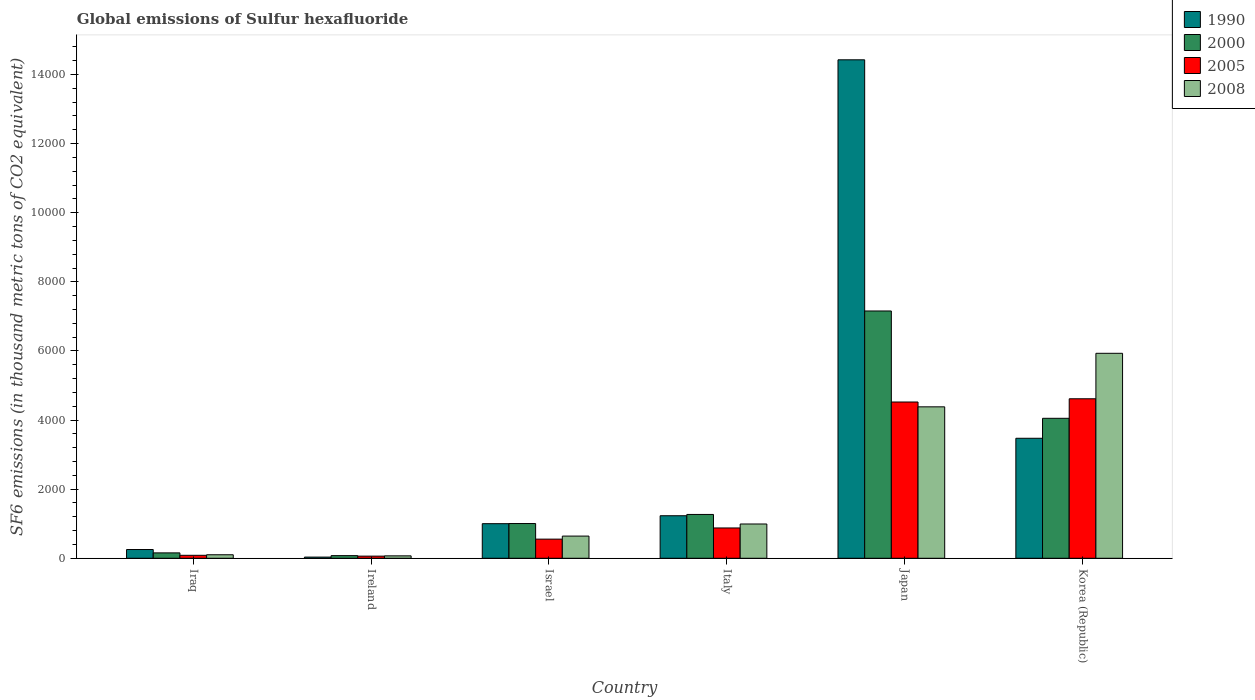Are the number of bars per tick equal to the number of legend labels?
Your answer should be very brief. Yes. How many bars are there on the 3rd tick from the right?
Your response must be concise. 4. What is the label of the 5th group of bars from the left?
Give a very brief answer. Japan. What is the global emissions of Sulfur hexafluoride in 2008 in Japan?
Keep it short and to the point. 4382.7. Across all countries, what is the maximum global emissions of Sulfur hexafluoride in 2005?
Offer a terse response. 4615.7. Across all countries, what is the minimum global emissions of Sulfur hexafluoride in 1990?
Offer a terse response. 33.8. In which country was the global emissions of Sulfur hexafluoride in 2000 minimum?
Keep it short and to the point. Ireland. What is the total global emissions of Sulfur hexafluoride in 1990 in the graph?
Your answer should be compact. 2.04e+04. What is the difference between the global emissions of Sulfur hexafluoride in 2005 in Iraq and that in Korea (Republic)?
Make the answer very short. -4529.7. What is the difference between the global emissions of Sulfur hexafluoride in 2008 in Japan and the global emissions of Sulfur hexafluoride in 2000 in Ireland?
Provide a succinct answer. 4306.2. What is the average global emissions of Sulfur hexafluoride in 2005 per country?
Your response must be concise. 1786.12. What is the difference between the global emissions of Sulfur hexafluoride of/in 2005 and global emissions of Sulfur hexafluoride of/in 1990 in Israel?
Ensure brevity in your answer.  -447.3. What is the ratio of the global emissions of Sulfur hexafluoride in 1990 in Iraq to that in Ireland?
Offer a terse response. 7.48. Is the global emissions of Sulfur hexafluoride in 2005 in Iraq less than that in Korea (Republic)?
Provide a short and direct response. Yes. Is the difference between the global emissions of Sulfur hexafluoride in 2005 in Iraq and Italy greater than the difference between the global emissions of Sulfur hexafluoride in 1990 in Iraq and Italy?
Ensure brevity in your answer.  Yes. What is the difference between the highest and the second highest global emissions of Sulfur hexafluoride in 2005?
Keep it short and to the point. 3645.1. What is the difference between the highest and the lowest global emissions of Sulfur hexafluoride in 1990?
Your response must be concise. 1.44e+04. In how many countries, is the global emissions of Sulfur hexafluoride in 1990 greater than the average global emissions of Sulfur hexafluoride in 1990 taken over all countries?
Your answer should be compact. 2. Is it the case that in every country, the sum of the global emissions of Sulfur hexafluoride in 2000 and global emissions of Sulfur hexafluoride in 1990 is greater than the sum of global emissions of Sulfur hexafluoride in 2008 and global emissions of Sulfur hexafluoride in 2005?
Ensure brevity in your answer.  No. What does the 3rd bar from the right in Japan represents?
Your answer should be compact. 2000. Is it the case that in every country, the sum of the global emissions of Sulfur hexafluoride in 2000 and global emissions of Sulfur hexafluoride in 2008 is greater than the global emissions of Sulfur hexafluoride in 1990?
Provide a short and direct response. No. How many bars are there?
Offer a very short reply. 24. How many countries are there in the graph?
Give a very brief answer. 6. Are the values on the major ticks of Y-axis written in scientific E-notation?
Make the answer very short. No. Does the graph contain any zero values?
Provide a succinct answer. No. Does the graph contain grids?
Your answer should be compact. No. How many legend labels are there?
Your answer should be compact. 4. What is the title of the graph?
Your answer should be very brief. Global emissions of Sulfur hexafluoride. What is the label or title of the X-axis?
Offer a very short reply. Country. What is the label or title of the Y-axis?
Offer a very short reply. SF6 emissions (in thousand metric tons of CO2 equivalent). What is the SF6 emissions (in thousand metric tons of CO2 equivalent) of 1990 in Iraq?
Give a very brief answer. 252.9. What is the SF6 emissions (in thousand metric tons of CO2 equivalent) of 2000 in Iraq?
Give a very brief answer. 156.1. What is the SF6 emissions (in thousand metric tons of CO2 equivalent) in 2005 in Iraq?
Ensure brevity in your answer.  86. What is the SF6 emissions (in thousand metric tons of CO2 equivalent) of 2008 in Iraq?
Offer a very short reply. 101.7. What is the SF6 emissions (in thousand metric tons of CO2 equivalent) in 1990 in Ireland?
Your answer should be compact. 33.8. What is the SF6 emissions (in thousand metric tons of CO2 equivalent) in 2000 in Ireland?
Provide a short and direct response. 76.5. What is the SF6 emissions (in thousand metric tons of CO2 equivalent) of 2005 in Ireland?
Make the answer very short. 61.8. What is the SF6 emissions (in thousand metric tons of CO2 equivalent) in 2008 in Ireland?
Keep it short and to the point. 69.9. What is the SF6 emissions (in thousand metric tons of CO2 equivalent) of 1990 in Israel?
Provide a succinct answer. 1001. What is the SF6 emissions (in thousand metric tons of CO2 equivalent) of 2000 in Israel?
Ensure brevity in your answer.  1005.2. What is the SF6 emissions (in thousand metric tons of CO2 equivalent) in 2005 in Israel?
Your answer should be compact. 553.7. What is the SF6 emissions (in thousand metric tons of CO2 equivalent) in 2008 in Israel?
Your answer should be very brief. 642. What is the SF6 emissions (in thousand metric tons of CO2 equivalent) of 1990 in Italy?
Provide a short and direct response. 1230.8. What is the SF6 emissions (in thousand metric tons of CO2 equivalent) in 2000 in Italy?
Provide a succinct answer. 1268.5. What is the SF6 emissions (in thousand metric tons of CO2 equivalent) in 2005 in Italy?
Ensure brevity in your answer.  877.2. What is the SF6 emissions (in thousand metric tons of CO2 equivalent) in 2008 in Italy?
Provide a short and direct response. 992.1. What is the SF6 emissions (in thousand metric tons of CO2 equivalent) of 1990 in Japan?
Make the answer very short. 1.44e+04. What is the SF6 emissions (in thousand metric tons of CO2 equivalent) of 2000 in Japan?
Offer a very short reply. 7156.6. What is the SF6 emissions (in thousand metric tons of CO2 equivalent) of 2005 in Japan?
Ensure brevity in your answer.  4522.3. What is the SF6 emissions (in thousand metric tons of CO2 equivalent) in 2008 in Japan?
Your response must be concise. 4382.7. What is the SF6 emissions (in thousand metric tons of CO2 equivalent) of 1990 in Korea (Republic)?
Keep it short and to the point. 3472.9. What is the SF6 emissions (in thousand metric tons of CO2 equivalent) of 2000 in Korea (Republic)?
Make the answer very short. 4050.5. What is the SF6 emissions (in thousand metric tons of CO2 equivalent) in 2005 in Korea (Republic)?
Make the answer very short. 4615.7. What is the SF6 emissions (in thousand metric tons of CO2 equivalent) in 2008 in Korea (Republic)?
Ensure brevity in your answer.  5931.6. Across all countries, what is the maximum SF6 emissions (in thousand metric tons of CO2 equivalent) in 1990?
Give a very brief answer. 1.44e+04. Across all countries, what is the maximum SF6 emissions (in thousand metric tons of CO2 equivalent) in 2000?
Make the answer very short. 7156.6. Across all countries, what is the maximum SF6 emissions (in thousand metric tons of CO2 equivalent) in 2005?
Ensure brevity in your answer.  4615.7. Across all countries, what is the maximum SF6 emissions (in thousand metric tons of CO2 equivalent) in 2008?
Ensure brevity in your answer.  5931.6. Across all countries, what is the minimum SF6 emissions (in thousand metric tons of CO2 equivalent) of 1990?
Your answer should be very brief. 33.8. Across all countries, what is the minimum SF6 emissions (in thousand metric tons of CO2 equivalent) in 2000?
Your response must be concise. 76.5. Across all countries, what is the minimum SF6 emissions (in thousand metric tons of CO2 equivalent) in 2005?
Your response must be concise. 61.8. Across all countries, what is the minimum SF6 emissions (in thousand metric tons of CO2 equivalent) in 2008?
Make the answer very short. 69.9. What is the total SF6 emissions (in thousand metric tons of CO2 equivalent) of 1990 in the graph?
Your answer should be very brief. 2.04e+04. What is the total SF6 emissions (in thousand metric tons of CO2 equivalent) in 2000 in the graph?
Give a very brief answer. 1.37e+04. What is the total SF6 emissions (in thousand metric tons of CO2 equivalent) of 2005 in the graph?
Make the answer very short. 1.07e+04. What is the total SF6 emissions (in thousand metric tons of CO2 equivalent) of 2008 in the graph?
Your answer should be very brief. 1.21e+04. What is the difference between the SF6 emissions (in thousand metric tons of CO2 equivalent) in 1990 in Iraq and that in Ireland?
Make the answer very short. 219.1. What is the difference between the SF6 emissions (in thousand metric tons of CO2 equivalent) in 2000 in Iraq and that in Ireland?
Your answer should be compact. 79.6. What is the difference between the SF6 emissions (in thousand metric tons of CO2 equivalent) in 2005 in Iraq and that in Ireland?
Ensure brevity in your answer.  24.2. What is the difference between the SF6 emissions (in thousand metric tons of CO2 equivalent) in 2008 in Iraq and that in Ireland?
Keep it short and to the point. 31.8. What is the difference between the SF6 emissions (in thousand metric tons of CO2 equivalent) in 1990 in Iraq and that in Israel?
Your response must be concise. -748.1. What is the difference between the SF6 emissions (in thousand metric tons of CO2 equivalent) in 2000 in Iraq and that in Israel?
Your answer should be compact. -849.1. What is the difference between the SF6 emissions (in thousand metric tons of CO2 equivalent) of 2005 in Iraq and that in Israel?
Provide a succinct answer. -467.7. What is the difference between the SF6 emissions (in thousand metric tons of CO2 equivalent) in 2008 in Iraq and that in Israel?
Offer a terse response. -540.3. What is the difference between the SF6 emissions (in thousand metric tons of CO2 equivalent) of 1990 in Iraq and that in Italy?
Ensure brevity in your answer.  -977.9. What is the difference between the SF6 emissions (in thousand metric tons of CO2 equivalent) of 2000 in Iraq and that in Italy?
Ensure brevity in your answer.  -1112.4. What is the difference between the SF6 emissions (in thousand metric tons of CO2 equivalent) in 2005 in Iraq and that in Italy?
Provide a short and direct response. -791.2. What is the difference between the SF6 emissions (in thousand metric tons of CO2 equivalent) of 2008 in Iraq and that in Italy?
Make the answer very short. -890.4. What is the difference between the SF6 emissions (in thousand metric tons of CO2 equivalent) of 1990 in Iraq and that in Japan?
Offer a terse response. -1.42e+04. What is the difference between the SF6 emissions (in thousand metric tons of CO2 equivalent) of 2000 in Iraq and that in Japan?
Your answer should be compact. -7000.5. What is the difference between the SF6 emissions (in thousand metric tons of CO2 equivalent) in 2005 in Iraq and that in Japan?
Keep it short and to the point. -4436.3. What is the difference between the SF6 emissions (in thousand metric tons of CO2 equivalent) in 2008 in Iraq and that in Japan?
Offer a very short reply. -4281. What is the difference between the SF6 emissions (in thousand metric tons of CO2 equivalent) of 1990 in Iraq and that in Korea (Republic)?
Your answer should be very brief. -3220. What is the difference between the SF6 emissions (in thousand metric tons of CO2 equivalent) of 2000 in Iraq and that in Korea (Republic)?
Your answer should be very brief. -3894.4. What is the difference between the SF6 emissions (in thousand metric tons of CO2 equivalent) in 2005 in Iraq and that in Korea (Republic)?
Your answer should be very brief. -4529.7. What is the difference between the SF6 emissions (in thousand metric tons of CO2 equivalent) of 2008 in Iraq and that in Korea (Republic)?
Offer a terse response. -5829.9. What is the difference between the SF6 emissions (in thousand metric tons of CO2 equivalent) in 1990 in Ireland and that in Israel?
Your answer should be compact. -967.2. What is the difference between the SF6 emissions (in thousand metric tons of CO2 equivalent) of 2000 in Ireland and that in Israel?
Give a very brief answer. -928.7. What is the difference between the SF6 emissions (in thousand metric tons of CO2 equivalent) in 2005 in Ireland and that in Israel?
Your answer should be very brief. -491.9. What is the difference between the SF6 emissions (in thousand metric tons of CO2 equivalent) of 2008 in Ireland and that in Israel?
Provide a short and direct response. -572.1. What is the difference between the SF6 emissions (in thousand metric tons of CO2 equivalent) in 1990 in Ireland and that in Italy?
Offer a terse response. -1197. What is the difference between the SF6 emissions (in thousand metric tons of CO2 equivalent) in 2000 in Ireland and that in Italy?
Your answer should be compact. -1192. What is the difference between the SF6 emissions (in thousand metric tons of CO2 equivalent) in 2005 in Ireland and that in Italy?
Provide a short and direct response. -815.4. What is the difference between the SF6 emissions (in thousand metric tons of CO2 equivalent) of 2008 in Ireland and that in Italy?
Your answer should be very brief. -922.2. What is the difference between the SF6 emissions (in thousand metric tons of CO2 equivalent) in 1990 in Ireland and that in Japan?
Keep it short and to the point. -1.44e+04. What is the difference between the SF6 emissions (in thousand metric tons of CO2 equivalent) in 2000 in Ireland and that in Japan?
Your answer should be very brief. -7080.1. What is the difference between the SF6 emissions (in thousand metric tons of CO2 equivalent) of 2005 in Ireland and that in Japan?
Provide a succinct answer. -4460.5. What is the difference between the SF6 emissions (in thousand metric tons of CO2 equivalent) in 2008 in Ireland and that in Japan?
Keep it short and to the point. -4312.8. What is the difference between the SF6 emissions (in thousand metric tons of CO2 equivalent) of 1990 in Ireland and that in Korea (Republic)?
Your answer should be compact. -3439.1. What is the difference between the SF6 emissions (in thousand metric tons of CO2 equivalent) in 2000 in Ireland and that in Korea (Republic)?
Keep it short and to the point. -3974. What is the difference between the SF6 emissions (in thousand metric tons of CO2 equivalent) of 2005 in Ireland and that in Korea (Republic)?
Provide a short and direct response. -4553.9. What is the difference between the SF6 emissions (in thousand metric tons of CO2 equivalent) in 2008 in Ireland and that in Korea (Republic)?
Provide a succinct answer. -5861.7. What is the difference between the SF6 emissions (in thousand metric tons of CO2 equivalent) of 1990 in Israel and that in Italy?
Keep it short and to the point. -229.8. What is the difference between the SF6 emissions (in thousand metric tons of CO2 equivalent) in 2000 in Israel and that in Italy?
Make the answer very short. -263.3. What is the difference between the SF6 emissions (in thousand metric tons of CO2 equivalent) of 2005 in Israel and that in Italy?
Your answer should be compact. -323.5. What is the difference between the SF6 emissions (in thousand metric tons of CO2 equivalent) of 2008 in Israel and that in Italy?
Provide a succinct answer. -350.1. What is the difference between the SF6 emissions (in thousand metric tons of CO2 equivalent) in 1990 in Israel and that in Japan?
Ensure brevity in your answer.  -1.34e+04. What is the difference between the SF6 emissions (in thousand metric tons of CO2 equivalent) of 2000 in Israel and that in Japan?
Your answer should be compact. -6151.4. What is the difference between the SF6 emissions (in thousand metric tons of CO2 equivalent) in 2005 in Israel and that in Japan?
Your answer should be very brief. -3968.6. What is the difference between the SF6 emissions (in thousand metric tons of CO2 equivalent) of 2008 in Israel and that in Japan?
Offer a terse response. -3740.7. What is the difference between the SF6 emissions (in thousand metric tons of CO2 equivalent) in 1990 in Israel and that in Korea (Republic)?
Your answer should be compact. -2471.9. What is the difference between the SF6 emissions (in thousand metric tons of CO2 equivalent) of 2000 in Israel and that in Korea (Republic)?
Offer a very short reply. -3045.3. What is the difference between the SF6 emissions (in thousand metric tons of CO2 equivalent) in 2005 in Israel and that in Korea (Republic)?
Your response must be concise. -4062. What is the difference between the SF6 emissions (in thousand metric tons of CO2 equivalent) in 2008 in Israel and that in Korea (Republic)?
Provide a succinct answer. -5289.6. What is the difference between the SF6 emissions (in thousand metric tons of CO2 equivalent) in 1990 in Italy and that in Japan?
Ensure brevity in your answer.  -1.32e+04. What is the difference between the SF6 emissions (in thousand metric tons of CO2 equivalent) of 2000 in Italy and that in Japan?
Ensure brevity in your answer.  -5888.1. What is the difference between the SF6 emissions (in thousand metric tons of CO2 equivalent) of 2005 in Italy and that in Japan?
Provide a short and direct response. -3645.1. What is the difference between the SF6 emissions (in thousand metric tons of CO2 equivalent) of 2008 in Italy and that in Japan?
Keep it short and to the point. -3390.6. What is the difference between the SF6 emissions (in thousand metric tons of CO2 equivalent) of 1990 in Italy and that in Korea (Republic)?
Give a very brief answer. -2242.1. What is the difference between the SF6 emissions (in thousand metric tons of CO2 equivalent) of 2000 in Italy and that in Korea (Republic)?
Make the answer very short. -2782. What is the difference between the SF6 emissions (in thousand metric tons of CO2 equivalent) of 2005 in Italy and that in Korea (Republic)?
Your answer should be very brief. -3738.5. What is the difference between the SF6 emissions (in thousand metric tons of CO2 equivalent) of 2008 in Italy and that in Korea (Republic)?
Offer a terse response. -4939.5. What is the difference between the SF6 emissions (in thousand metric tons of CO2 equivalent) of 1990 in Japan and that in Korea (Republic)?
Your response must be concise. 1.10e+04. What is the difference between the SF6 emissions (in thousand metric tons of CO2 equivalent) of 2000 in Japan and that in Korea (Republic)?
Keep it short and to the point. 3106.1. What is the difference between the SF6 emissions (in thousand metric tons of CO2 equivalent) of 2005 in Japan and that in Korea (Republic)?
Offer a terse response. -93.4. What is the difference between the SF6 emissions (in thousand metric tons of CO2 equivalent) of 2008 in Japan and that in Korea (Republic)?
Make the answer very short. -1548.9. What is the difference between the SF6 emissions (in thousand metric tons of CO2 equivalent) of 1990 in Iraq and the SF6 emissions (in thousand metric tons of CO2 equivalent) of 2000 in Ireland?
Your answer should be compact. 176.4. What is the difference between the SF6 emissions (in thousand metric tons of CO2 equivalent) of 1990 in Iraq and the SF6 emissions (in thousand metric tons of CO2 equivalent) of 2005 in Ireland?
Provide a short and direct response. 191.1. What is the difference between the SF6 emissions (in thousand metric tons of CO2 equivalent) of 1990 in Iraq and the SF6 emissions (in thousand metric tons of CO2 equivalent) of 2008 in Ireland?
Your answer should be very brief. 183. What is the difference between the SF6 emissions (in thousand metric tons of CO2 equivalent) of 2000 in Iraq and the SF6 emissions (in thousand metric tons of CO2 equivalent) of 2005 in Ireland?
Give a very brief answer. 94.3. What is the difference between the SF6 emissions (in thousand metric tons of CO2 equivalent) of 2000 in Iraq and the SF6 emissions (in thousand metric tons of CO2 equivalent) of 2008 in Ireland?
Your answer should be compact. 86.2. What is the difference between the SF6 emissions (in thousand metric tons of CO2 equivalent) of 1990 in Iraq and the SF6 emissions (in thousand metric tons of CO2 equivalent) of 2000 in Israel?
Provide a succinct answer. -752.3. What is the difference between the SF6 emissions (in thousand metric tons of CO2 equivalent) in 1990 in Iraq and the SF6 emissions (in thousand metric tons of CO2 equivalent) in 2005 in Israel?
Keep it short and to the point. -300.8. What is the difference between the SF6 emissions (in thousand metric tons of CO2 equivalent) of 1990 in Iraq and the SF6 emissions (in thousand metric tons of CO2 equivalent) of 2008 in Israel?
Give a very brief answer. -389.1. What is the difference between the SF6 emissions (in thousand metric tons of CO2 equivalent) in 2000 in Iraq and the SF6 emissions (in thousand metric tons of CO2 equivalent) in 2005 in Israel?
Give a very brief answer. -397.6. What is the difference between the SF6 emissions (in thousand metric tons of CO2 equivalent) in 2000 in Iraq and the SF6 emissions (in thousand metric tons of CO2 equivalent) in 2008 in Israel?
Keep it short and to the point. -485.9. What is the difference between the SF6 emissions (in thousand metric tons of CO2 equivalent) in 2005 in Iraq and the SF6 emissions (in thousand metric tons of CO2 equivalent) in 2008 in Israel?
Offer a very short reply. -556. What is the difference between the SF6 emissions (in thousand metric tons of CO2 equivalent) in 1990 in Iraq and the SF6 emissions (in thousand metric tons of CO2 equivalent) in 2000 in Italy?
Your answer should be compact. -1015.6. What is the difference between the SF6 emissions (in thousand metric tons of CO2 equivalent) in 1990 in Iraq and the SF6 emissions (in thousand metric tons of CO2 equivalent) in 2005 in Italy?
Ensure brevity in your answer.  -624.3. What is the difference between the SF6 emissions (in thousand metric tons of CO2 equivalent) in 1990 in Iraq and the SF6 emissions (in thousand metric tons of CO2 equivalent) in 2008 in Italy?
Your answer should be compact. -739.2. What is the difference between the SF6 emissions (in thousand metric tons of CO2 equivalent) in 2000 in Iraq and the SF6 emissions (in thousand metric tons of CO2 equivalent) in 2005 in Italy?
Offer a terse response. -721.1. What is the difference between the SF6 emissions (in thousand metric tons of CO2 equivalent) of 2000 in Iraq and the SF6 emissions (in thousand metric tons of CO2 equivalent) of 2008 in Italy?
Make the answer very short. -836. What is the difference between the SF6 emissions (in thousand metric tons of CO2 equivalent) in 2005 in Iraq and the SF6 emissions (in thousand metric tons of CO2 equivalent) in 2008 in Italy?
Offer a terse response. -906.1. What is the difference between the SF6 emissions (in thousand metric tons of CO2 equivalent) in 1990 in Iraq and the SF6 emissions (in thousand metric tons of CO2 equivalent) in 2000 in Japan?
Your response must be concise. -6903.7. What is the difference between the SF6 emissions (in thousand metric tons of CO2 equivalent) of 1990 in Iraq and the SF6 emissions (in thousand metric tons of CO2 equivalent) of 2005 in Japan?
Make the answer very short. -4269.4. What is the difference between the SF6 emissions (in thousand metric tons of CO2 equivalent) in 1990 in Iraq and the SF6 emissions (in thousand metric tons of CO2 equivalent) in 2008 in Japan?
Provide a short and direct response. -4129.8. What is the difference between the SF6 emissions (in thousand metric tons of CO2 equivalent) in 2000 in Iraq and the SF6 emissions (in thousand metric tons of CO2 equivalent) in 2005 in Japan?
Offer a very short reply. -4366.2. What is the difference between the SF6 emissions (in thousand metric tons of CO2 equivalent) in 2000 in Iraq and the SF6 emissions (in thousand metric tons of CO2 equivalent) in 2008 in Japan?
Your response must be concise. -4226.6. What is the difference between the SF6 emissions (in thousand metric tons of CO2 equivalent) in 2005 in Iraq and the SF6 emissions (in thousand metric tons of CO2 equivalent) in 2008 in Japan?
Keep it short and to the point. -4296.7. What is the difference between the SF6 emissions (in thousand metric tons of CO2 equivalent) in 1990 in Iraq and the SF6 emissions (in thousand metric tons of CO2 equivalent) in 2000 in Korea (Republic)?
Your answer should be compact. -3797.6. What is the difference between the SF6 emissions (in thousand metric tons of CO2 equivalent) of 1990 in Iraq and the SF6 emissions (in thousand metric tons of CO2 equivalent) of 2005 in Korea (Republic)?
Offer a terse response. -4362.8. What is the difference between the SF6 emissions (in thousand metric tons of CO2 equivalent) in 1990 in Iraq and the SF6 emissions (in thousand metric tons of CO2 equivalent) in 2008 in Korea (Republic)?
Offer a terse response. -5678.7. What is the difference between the SF6 emissions (in thousand metric tons of CO2 equivalent) in 2000 in Iraq and the SF6 emissions (in thousand metric tons of CO2 equivalent) in 2005 in Korea (Republic)?
Give a very brief answer. -4459.6. What is the difference between the SF6 emissions (in thousand metric tons of CO2 equivalent) of 2000 in Iraq and the SF6 emissions (in thousand metric tons of CO2 equivalent) of 2008 in Korea (Republic)?
Keep it short and to the point. -5775.5. What is the difference between the SF6 emissions (in thousand metric tons of CO2 equivalent) of 2005 in Iraq and the SF6 emissions (in thousand metric tons of CO2 equivalent) of 2008 in Korea (Republic)?
Ensure brevity in your answer.  -5845.6. What is the difference between the SF6 emissions (in thousand metric tons of CO2 equivalent) in 1990 in Ireland and the SF6 emissions (in thousand metric tons of CO2 equivalent) in 2000 in Israel?
Ensure brevity in your answer.  -971.4. What is the difference between the SF6 emissions (in thousand metric tons of CO2 equivalent) in 1990 in Ireland and the SF6 emissions (in thousand metric tons of CO2 equivalent) in 2005 in Israel?
Your response must be concise. -519.9. What is the difference between the SF6 emissions (in thousand metric tons of CO2 equivalent) of 1990 in Ireland and the SF6 emissions (in thousand metric tons of CO2 equivalent) of 2008 in Israel?
Provide a short and direct response. -608.2. What is the difference between the SF6 emissions (in thousand metric tons of CO2 equivalent) in 2000 in Ireland and the SF6 emissions (in thousand metric tons of CO2 equivalent) in 2005 in Israel?
Keep it short and to the point. -477.2. What is the difference between the SF6 emissions (in thousand metric tons of CO2 equivalent) in 2000 in Ireland and the SF6 emissions (in thousand metric tons of CO2 equivalent) in 2008 in Israel?
Your answer should be very brief. -565.5. What is the difference between the SF6 emissions (in thousand metric tons of CO2 equivalent) in 2005 in Ireland and the SF6 emissions (in thousand metric tons of CO2 equivalent) in 2008 in Israel?
Offer a very short reply. -580.2. What is the difference between the SF6 emissions (in thousand metric tons of CO2 equivalent) of 1990 in Ireland and the SF6 emissions (in thousand metric tons of CO2 equivalent) of 2000 in Italy?
Your response must be concise. -1234.7. What is the difference between the SF6 emissions (in thousand metric tons of CO2 equivalent) of 1990 in Ireland and the SF6 emissions (in thousand metric tons of CO2 equivalent) of 2005 in Italy?
Provide a succinct answer. -843.4. What is the difference between the SF6 emissions (in thousand metric tons of CO2 equivalent) of 1990 in Ireland and the SF6 emissions (in thousand metric tons of CO2 equivalent) of 2008 in Italy?
Your response must be concise. -958.3. What is the difference between the SF6 emissions (in thousand metric tons of CO2 equivalent) of 2000 in Ireland and the SF6 emissions (in thousand metric tons of CO2 equivalent) of 2005 in Italy?
Give a very brief answer. -800.7. What is the difference between the SF6 emissions (in thousand metric tons of CO2 equivalent) in 2000 in Ireland and the SF6 emissions (in thousand metric tons of CO2 equivalent) in 2008 in Italy?
Make the answer very short. -915.6. What is the difference between the SF6 emissions (in thousand metric tons of CO2 equivalent) of 2005 in Ireland and the SF6 emissions (in thousand metric tons of CO2 equivalent) of 2008 in Italy?
Your answer should be compact. -930.3. What is the difference between the SF6 emissions (in thousand metric tons of CO2 equivalent) of 1990 in Ireland and the SF6 emissions (in thousand metric tons of CO2 equivalent) of 2000 in Japan?
Give a very brief answer. -7122.8. What is the difference between the SF6 emissions (in thousand metric tons of CO2 equivalent) of 1990 in Ireland and the SF6 emissions (in thousand metric tons of CO2 equivalent) of 2005 in Japan?
Your answer should be compact. -4488.5. What is the difference between the SF6 emissions (in thousand metric tons of CO2 equivalent) in 1990 in Ireland and the SF6 emissions (in thousand metric tons of CO2 equivalent) in 2008 in Japan?
Keep it short and to the point. -4348.9. What is the difference between the SF6 emissions (in thousand metric tons of CO2 equivalent) in 2000 in Ireland and the SF6 emissions (in thousand metric tons of CO2 equivalent) in 2005 in Japan?
Give a very brief answer. -4445.8. What is the difference between the SF6 emissions (in thousand metric tons of CO2 equivalent) of 2000 in Ireland and the SF6 emissions (in thousand metric tons of CO2 equivalent) of 2008 in Japan?
Offer a terse response. -4306.2. What is the difference between the SF6 emissions (in thousand metric tons of CO2 equivalent) of 2005 in Ireland and the SF6 emissions (in thousand metric tons of CO2 equivalent) of 2008 in Japan?
Provide a short and direct response. -4320.9. What is the difference between the SF6 emissions (in thousand metric tons of CO2 equivalent) in 1990 in Ireland and the SF6 emissions (in thousand metric tons of CO2 equivalent) in 2000 in Korea (Republic)?
Make the answer very short. -4016.7. What is the difference between the SF6 emissions (in thousand metric tons of CO2 equivalent) of 1990 in Ireland and the SF6 emissions (in thousand metric tons of CO2 equivalent) of 2005 in Korea (Republic)?
Provide a succinct answer. -4581.9. What is the difference between the SF6 emissions (in thousand metric tons of CO2 equivalent) of 1990 in Ireland and the SF6 emissions (in thousand metric tons of CO2 equivalent) of 2008 in Korea (Republic)?
Provide a short and direct response. -5897.8. What is the difference between the SF6 emissions (in thousand metric tons of CO2 equivalent) of 2000 in Ireland and the SF6 emissions (in thousand metric tons of CO2 equivalent) of 2005 in Korea (Republic)?
Provide a succinct answer. -4539.2. What is the difference between the SF6 emissions (in thousand metric tons of CO2 equivalent) of 2000 in Ireland and the SF6 emissions (in thousand metric tons of CO2 equivalent) of 2008 in Korea (Republic)?
Your answer should be compact. -5855.1. What is the difference between the SF6 emissions (in thousand metric tons of CO2 equivalent) in 2005 in Ireland and the SF6 emissions (in thousand metric tons of CO2 equivalent) in 2008 in Korea (Republic)?
Your response must be concise. -5869.8. What is the difference between the SF6 emissions (in thousand metric tons of CO2 equivalent) of 1990 in Israel and the SF6 emissions (in thousand metric tons of CO2 equivalent) of 2000 in Italy?
Keep it short and to the point. -267.5. What is the difference between the SF6 emissions (in thousand metric tons of CO2 equivalent) in 1990 in Israel and the SF6 emissions (in thousand metric tons of CO2 equivalent) in 2005 in Italy?
Provide a succinct answer. 123.8. What is the difference between the SF6 emissions (in thousand metric tons of CO2 equivalent) of 1990 in Israel and the SF6 emissions (in thousand metric tons of CO2 equivalent) of 2008 in Italy?
Provide a short and direct response. 8.9. What is the difference between the SF6 emissions (in thousand metric tons of CO2 equivalent) of 2000 in Israel and the SF6 emissions (in thousand metric tons of CO2 equivalent) of 2005 in Italy?
Offer a terse response. 128. What is the difference between the SF6 emissions (in thousand metric tons of CO2 equivalent) in 2000 in Israel and the SF6 emissions (in thousand metric tons of CO2 equivalent) in 2008 in Italy?
Your answer should be compact. 13.1. What is the difference between the SF6 emissions (in thousand metric tons of CO2 equivalent) of 2005 in Israel and the SF6 emissions (in thousand metric tons of CO2 equivalent) of 2008 in Italy?
Provide a succinct answer. -438.4. What is the difference between the SF6 emissions (in thousand metric tons of CO2 equivalent) in 1990 in Israel and the SF6 emissions (in thousand metric tons of CO2 equivalent) in 2000 in Japan?
Make the answer very short. -6155.6. What is the difference between the SF6 emissions (in thousand metric tons of CO2 equivalent) of 1990 in Israel and the SF6 emissions (in thousand metric tons of CO2 equivalent) of 2005 in Japan?
Offer a terse response. -3521.3. What is the difference between the SF6 emissions (in thousand metric tons of CO2 equivalent) in 1990 in Israel and the SF6 emissions (in thousand metric tons of CO2 equivalent) in 2008 in Japan?
Give a very brief answer. -3381.7. What is the difference between the SF6 emissions (in thousand metric tons of CO2 equivalent) in 2000 in Israel and the SF6 emissions (in thousand metric tons of CO2 equivalent) in 2005 in Japan?
Give a very brief answer. -3517.1. What is the difference between the SF6 emissions (in thousand metric tons of CO2 equivalent) in 2000 in Israel and the SF6 emissions (in thousand metric tons of CO2 equivalent) in 2008 in Japan?
Give a very brief answer. -3377.5. What is the difference between the SF6 emissions (in thousand metric tons of CO2 equivalent) of 2005 in Israel and the SF6 emissions (in thousand metric tons of CO2 equivalent) of 2008 in Japan?
Provide a succinct answer. -3829. What is the difference between the SF6 emissions (in thousand metric tons of CO2 equivalent) in 1990 in Israel and the SF6 emissions (in thousand metric tons of CO2 equivalent) in 2000 in Korea (Republic)?
Give a very brief answer. -3049.5. What is the difference between the SF6 emissions (in thousand metric tons of CO2 equivalent) of 1990 in Israel and the SF6 emissions (in thousand metric tons of CO2 equivalent) of 2005 in Korea (Republic)?
Your response must be concise. -3614.7. What is the difference between the SF6 emissions (in thousand metric tons of CO2 equivalent) of 1990 in Israel and the SF6 emissions (in thousand metric tons of CO2 equivalent) of 2008 in Korea (Republic)?
Make the answer very short. -4930.6. What is the difference between the SF6 emissions (in thousand metric tons of CO2 equivalent) in 2000 in Israel and the SF6 emissions (in thousand metric tons of CO2 equivalent) in 2005 in Korea (Republic)?
Offer a very short reply. -3610.5. What is the difference between the SF6 emissions (in thousand metric tons of CO2 equivalent) in 2000 in Israel and the SF6 emissions (in thousand metric tons of CO2 equivalent) in 2008 in Korea (Republic)?
Give a very brief answer. -4926.4. What is the difference between the SF6 emissions (in thousand metric tons of CO2 equivalent) of 2005 in Israel and the SF6 emissions (in thousand metric tons of CO2 equivalent) of 2008 in Korea (Republic)?
Make the answer very short. -5377.9. What is the difference between the SF6 emissions (in thousand metric tons of CO2 equivalent) in 1990 in Italy and the SF6 emissions (in thousand metric tons of CO2 equivalent) in 2000 in Japan?
Ensure brevity in your answer.  -5925.8. What is the difference between the SF6 emissions (in thousand metric tons of CO2 equivalent) of 1990 in Italy and the SF6 emissions (in thousand metric tons of CO2 equivalent) of 2005 in Japan?
Give a very brief answer. -3291.5. What is the difference between the SF6 emissions (in thousand metric tons of CO2 equivalent) of 1990 in Italy and the SF6 emissions (in thousand metric tons of CO2 equivalent) of 2008 in Japan?
Give a very brief answer. -3151.9. What is the difference between the SF6 emissions (in thousand metric tons of CO2 equivalent) of 2000 in Italy and the SF6 emissions (in thousand metric tons of CO2 equivalent) of 2005 in Japan?
Provide a succinct answer. -3253.8. What is the difference between the SF6 emissions (in thousand metric tons of CO2 equivalent) in 2000 in Italy and the SF6 emissions (in thousand metric tons of CO2 equivalent) in 2008 in Japan?
Provide a short and direct response. -3114.2. What is the difference between the SF6 emissions (in thousand metric tons of CO2 equivalent) in 2005 in Italy and the SF6 emissions (in thousand metric tons of CO2 equivalent) in 2008 in Japan?
Your answer should be very brief. -3505.5. What is the difference between the SF6 emissions (in thousand metric tons of CO2 equivalent) in 1990 in Italy and the SF6 emissions (in thousand metric tons of CO2 equivalent) in 2000 in Korea (Republic)?
Make the answer very short. -2819.7. What is the difference between the SF6 emissions (in thousand metric tons of CO2 equivalent) in 1990 in Italy and the SF6 emissions (in thousand metric tons of CO2 equivalent) in 2005 in Korea (Republic)?
Provide a short and direct response. -3384.9. What is the difference between the SF6 emissions (in thousand metric tons of CO2 equivalent) of 1990 in Italy and the SF6 emissions (in thousand metric tons of CO2 equivalent) of 2008 in Korea (Republic)?
Provide a succinct answer. -4700.8. What is the difference between the SF6 emissions (in thousand metric tons of CO2 equivalent) of 2000 in Italy and the SF6 emissions (in thousand metric tons of CO2 equivalent) of 2005 in Korea (Republic)?
Offer a terse response. -3347.2. What is the difference between the SF6 emissions (in thousand metric tons of CO2 equivalent) in 2000 in Italy and the SF6 emissions (in thousand metric tons of CO2 equivalent) in 2008 in Korea (Republic)?
Offer a terse response. -4663.1. What is the difference between the SF6 emissions (in thousand metric tons of CO2 equivalent) in 2005 in Italy and the SF6 emissions (in thousand metric tons of CO2 equivalent) in 2008 in Korea (Republic)?
Give a very brief answer. -5054.4. What is the difference between the SF6 emissions (in thousand metric tons of CO2 equivalent) of 1990 in Japan and the SF6 emissions (in thousand metric tons of CO2 equivalent) of 2000 in Korea (Republic)?
Ensure brevity in your answer.  1.04e+04. What is the difference between the SF6 emissions (in thousand metric tons of CO2 equivalent) of 1990 in Japan and the SF6 emissions (in thousand metric tons of CO2 equivalent) of 2005 in Korea (Republic)?
Provide a short and direct response. 9810.1. What is the difference between the SF6 emissions (in thousand metric tons of CO2 equivalent) of 1990 in Japan and the SF6 emissions (in thousand metric tons of CO2 equivalent) of 2008 in Korea (Republic)?
Ensure brevity in your answer.  8494.2. What is the difference between the SF6 emissions (in thousand metric tons of CO2 equivalent) in 2000 in Japan and the SF6 emissions (in thousand metric tons of CO2 equivalent) in 2005 in Korea (Republic)?
Give a very brief answer. 2540.9. What is the difference between the SF6 emissions (in thousand metric tons of CO2 equivalent) in 2000 in Japan and the SF6 emissions (in thousand metric tons of CO2 equivalent) in 2008 in Korea (Republic)?
Your response must be concise. 1225. What is the difference between the SF6 emissions (in thousand metric tons of CO2 equivalent) in 2005 in Japan and the SF6 emissions (in thousand metric tons of CO2 equivalent) in 2008 in Korea (Republic)?
Make the answer very short. -1409.3. What is the average SF6 emissions (in thousand metric tons of CO2 equivalent) of 1990 per country?
Provide a succinct answer. 3402.87. What is the average SF6 emissions (in thousand metric tons of CO2 equivalent) in 2000 per country?
Offer a very short reply. 2285.57. What is the average SF6 emissions (in thousand metric tons of CO2 equivalent) of 2005 per country?
Ensure brevity in your answer.  1786.12. What is the average SF6 emissions (in thousand metric tons of CO2 equivalent) of 2008 per country?
Offer a very short reply. 2020. What is the difference between the SF6 emissions (in thousand metric tons of CO2 equivalent) in 1990 and SF6 emissions (in thousand metric tons of CO2 equivalent) in 2000 in Iraq?
Ensure brevity in your answer.  96.8. What is the difference between the SF6 emissions (in thousand metric tons of CO2 equivalent) in 1990 and SF6 emissions (in thousand metric tons of CO2 equivalent) in 2005 in Iraq?
Ensure brevity in your answer.  166.9. What is the difference between the SF6 emissions (in thousand metric tons of CO2 equivalent) in 1990 and SF6 emissions (in thousand metric tons of CO2 equivalent) in 2008 in Iraq?
Your answer should be very brief. 151.2. What is the difference between the SF6 emissions (in thousand metric tons of CO2 equivalent) of 2000 and SF6 emissions (in thousand metric tons of CO2 equivalent) of 2005 in Iraq?
Your response must be concise. 70.1. What is the difference between the SF6 emissions (in thousand metric tons of CO2 equivalent) in 2000 and SF6 emissions (in thousand metric tons of CO2 equivalent) in 2008 in Iraq?
Your answer should be compact. 54.4. What is the difference between the SF6 emissions (in thousand metric tons of CO2 equivalent) in 2005 and SF6 emissions (in thousand metric tons of CO2 equivalent) in 2008 in Iraq?
Your answer should be very brief. -15.7. What is the difference between the SF6 emissions (in thousand metric tons of CO2 equivalent) of 1990 and SF6 emissions (in thousand metric tons of CO2 equivalent) of 2000 in Ireland?
Offer a very short reply. -42.7. What is the difference between the SF6 emissions (in thousand metric tons of CO2 equivalent) of 1990 and SF6 emissions (in thousand metric tons of CO2 equivalent) of 2005 in Ireland?
Keep it short and to the point. -28. What is the difference between the SF6 emissions (in thousand metric tons of CO2 equivalent) in 1990 and SF6 emissions (in thousand metric tons of CO2 equivalent) in 2008 in Ireland?
Your response must be concise. -36.1. What is the difference between the SF6 emissions (in thousand metric tons of CO2 equivalent) in 2000 and SF6 emissions (in thousand metric tons of CO2 equivalent) in 2008 in Ireland?
Give a very brief answer. 6.6. What is the difference between the SF6 emissions (in thousand metric tons of CO2 equivalent) of 2005 and SF6 emissions (in thousand metric tons of CO2 equivalent) of 2008 in Ireland?
Your answer should be very brief. -8.1. What is the difference between the SF6 emissions (in thousand metric tons of CO2 equivalent) of 1990 and SF6 emissions (in thousand metric tons of CO2 equivalent) of 2005 in Israel?
Provide a succinct answer. 447.3. What is the difference between the SF6 emissions (in thousand metric tons of CO2 equivalent) in 1990 and SF6 emissions (in thousand metric tons of CO2 equivalent) in 2008 in Israel?
Ensure brevity in your answer.  359. What is the difference between the SF6 emissions (in thousand metric tons of CO2 equivalent) in 2000 and SF6 emissions (in thousand metric tons of CO2 equivalent) in 2005 in Israel?
Offer a terse response. 451.5. What is the difference between the SF6 emissions (in thousand metric tons of CO2 equivalent) of 2000 and SF6 emissions (in thousand metric tons of CO2 equivalent) of 2008 in Israel?
Make the answer very short. 363.2. What is the difference between the SF6 emissions (in thousand metric tons of CO2 equivalent) in 2005 and SF6 emissions (in thousand metric tons of CO2 equivalent) in 2008 in Israel?
Provide a short and direct response. -88.3. What is the difference between the SF6 emissions (in thousand metric tons of CO2 equivalent) of 1990 and SF6 emissions (in thousand metric tons of CO2 equivalent) of 2000 in Italy?
Provide a short and direct response. -37.7. What is the difference between the SF6 emissions (in thousand metric tons of CO2 equivalent) in 1990 and SF6 emissions (in thousand metric tons of CO2 equivalent) in 2005 in Italy?
Ensure brevity in your answer.  353.6. What is the difference between the SF6 emissions (in thousand metric tons of CO2 equivalent) in 1990 and SF6 emissions (in thousand metric tons of CO2 equivalent) in 2008 in Italy?
Keep it short and to the point. 238.7. What is the difference between the SF6 emissions (in thousand metric tons of CO2 equivalent) in 2000 and SF6 emissions (in thousand metric tons of CO2 equivalent) in 2005 in Italy?
Ensure brevity in your answer.  391.3. What is the difference between the SF6 emissions (in thousand metric tons of CO2 equivalent) of 2000 and SF6 emissions (in thousand metric tons of CO2 equivalent) of 2008 in Italy?
Ensure brevity in your answer.  276.4. What is the difference between the SF6 emissions (in thousand metric tons of CO2 equivalent) in 2005 and SF6 emissions (in thousand metric tons of CO2 equivalent) in 2008 in Italy?
Make the answer very short. -114.9. What is the difference between the SF6 emissions (in thousand metric tons of CO2 equivalent) of 1990 and SF6 emissions (in thousand metric tons of CO2 equivalent) of 2000 in Japan?
Give a very brief answer. 7269.2. What is the difference between the SF6 emissions (in thousand metric tons of CO2 equivalent) of 1990 and SF6 emissions (in thousand metric tons of CO2 equivalent) of 2005 in Japan?
Your answer should be compact. 9903.5. What is the difference between the SF6 emissions (in thousand metric tons of CO2 equivalent) of 1990 and SF6 emissions (in thousand metric tons of CO2 equivalent) of 2008 in Japan?
Offer a very short reply. 1.00e+04. What is the difference between the SF6 emissions (in thousand metric tons of CO2 equivalent) of 2000 and SF6 emissions (in thousand metric tons of CO2 equivalent) of 2005 in Japan?
Provide a succinct answer. 2634.3. What is the difference between the SF6 emissions (in thousand metric tons of CO2 equivalent) in 2000 and SF6 emissions (in thousand metric tons of CO2 equivalent) in 2008 in Japan?
Your answer should be compact. 2773.9. What is the difference between the SF6 emissions (in thousand metric tons of CO2 equivalent) of 2005 and SF6 emissions (in thousand metric tons of CO2 equivalent) of 2008 in Japan?
Your answer should be compact. 139.6. What is the difference between the SF6 emissions (in thousand metric tons of CO2 equivalent) of 1990 and SF6 emissions (in thousand metric tons of CO2 equivalent) of 2000 in Korea (Republic)?
Give a very brief answer. -577.6. What is the difference between the SF6 emissions (in thousand metric tons of CO2 equivalent) of 1990 and SF6 emissions (in thousand metric tons of CO2 equivalent) of 2005 in Korea (Republic)?
Your response must be concise. -1142.8. What is the difference between the SF6 emissions (in thousand metric tons of CO2 equivalent) in 1990 and SF6 emissions (in thousand metric tons of CO2 equivalent) in 2008 in Korea (Republic)?
Offer a terse response. -2458.7. What is the difference between the SF6 emissions (in thousand metric tons of CO2 equivalent) of 2000 and SF6 emissions (in thousand metric tons of CO2 equivalent) of 2005 in Korea (Republic)?
Your answer should be very brief. -565.2. What is the difference between the SF6 emissions (in thousand metric tons of CO2 equivalent) of 2000 and SF6 emissions (in thousand metric tons of CO2 equivalent) of 2008 in Korea (Republic)?
Ensure brevity in your answer.  -1881.1. What is the difference between the SF6 emissions (in thousand metric tons of CO2 equivalent) of 2005 and SF6 emissions (in thousand metric tons of CO2 equivalent) of 2008 in Korea (Republic)?
Ensure brevity in your answer.  -1315.9. What is the ratio of the SF6 emissions (in thousand metric tons of CO2 equivalent) of 1990 in Iraq to that in Ireland?
Make the answer very short. 7.48. What is the ratio of the SF6 emissions (in thousand metric tons of CO2 equivalent) of 2000 in Iraq to that in Ireland?
Your answer should be compact. 2.04. What is the ratio of the SF6 emissions (in thousand metric tons of CO2 equivalent) of 2005 in Iraq to that in Ireland?
Offer a very short reply. 1.39. What is the ratio of the SF6 emissions (in thousand metric tons of CO2 equivalent) in 2008 in Iraq to that in Ireland?
Your answer should be compact. 1.45. What is the ratio of the SF6 emissions (in thousand metric tons of CO2 equivalent) of 1990 in Iraq to that in Israel?
Ensure brevity in your answer.  0.25. What is the ratio of the SF6 emissions (in thousand metric tons of CO2 equivalent) of 2000 in Iraq to that in Israel?
Your answer should be compact. 0.16. What is the ratio of the SF6 emissions (in thousand metric tons of CO2 equivalent) in 2005 in Iraq to that in Israel?
Provide a succinct answer. 0.16. What is the ratio of the SF6 emissions (in thousand metric tons of CO2 equivalent) of 2008 in Iraq to that in Israel?
Your response must be concise. 0.16. What is the ratio of the SF6 emissions (in thousand metric tons of CO2 equivalent) of 1990 in Iraq to that in Italy?
Provide a short and direct response. 0.21. What is the ratio of the SF6 emissions (in thousand metric tons of CO2 equivalent) of 2000 in Iraq to that in Italy?
Ensure brevity in your answer.  0.12. What is the ratio of the SF6 emissions (in thousand metric tons of CO2 equivalent) of 2005 in Iraq to that in Italy?
Your response must be concise. 0.1. What is the ratio of the SF6 emissions (in thousand metric tons of CO2 equivalent) of 2008 in Iraq to that in Italy?
Provide a succinct answer. 0.1. What is the ratio of the SF6 emissions (in thousand metric tons of CO2 equivalent) in 1990 in Iraq to that in Japan?
Make the answer very short. 0.02. What is the ratio of the SF6 emissions (in thousand metric tons of CO2 equivalent) in 2000 in Iraq to that in Japan?
Your answer should be very brief. 0.02. What is the ratio of the SF6 emissions (in thousand metric tons of CO2 equivalent) of 2005 in Iraq to that in Japan?
Your answer should be very brief. 0.02. What is the ratio of the SF6 emissions (in thousand metric tons of CO2 equivalent) in 2008 in Iraq to that in Japan?
Provide a short and direct response. 0.02. What is the ratio of the SF6 emissions (in thousand metric tons of CO2 equivalent) in 1990 in Iraq to that in Korea (Republic)?
Offer a terse response. 0.07. What is the ratio of the SF6 emissions (in thousand metric tons of CO2 equivalent) of 2000 in Iraq to that in Korea (Republic)?
Ensure brevity in your answer.  0.04. What is the ratio of the SF6 emissions (in thousand metric tons of CO2 equivalent) of 2005 in Iraq to that in Korea (Republic)?
Your answer should be very brief. 0.02. What is the ratio of the SF6 emissions (in thousand metric tons of CO2 equivalent) in 2008 in Iraq to that in Korea (Republic)?
Give a very brief answer. 0.02. What is the ratio of the SF6 emissions (in thousand metric tons of CO2 equivalent) in 1990 in Ireland to that in Israel?
Give a very brief answer. 0.03. What is the ratio of the SF6 emissions (in thousand metric tons of CO2 equivalent) in 2000 in Ireland to that in Israel?
Make the answer very short. 0.08. What is the ratio of the SF6 emissions (in thousand metric tons of CO2 equivalent) of 2005 in Ireland to that in Israel?
Provide a succinct answer. 0.11. What is the ratio of the SF6 emissions (in thousand metric tons of CO2 equivalent) of 2008 in Ireland to that in Israel?
Offer a very short reply. 0.11. What is the ratio of the SF6 emissions (in thousand metric tons of CO2 equivalent) of 1990 in Ireland to that in Italy?
Your answer should be very brief. 0.03. What is the ratio of the SF6 emissions (in thousand metric tons of CO2 equivalent) of 2000 in Ireland to that in Italy?
Provide a succinct answer. 0.06. What is the ratio of the SF6 emissions (in thousand metric tons of CO2 equivalent) of 2005 in Ireland to that in Italy?
Your answer should be very brief. 0.07. What is the ratio of the SF6 emissions (in thousand metric tons of CO2 equivalent) of 2008 in Ireland to that in Italy?
Your answer should be very brief. 0.07. What is the ratio of the SF6 emissions (in thousand metric tons of CO2 equivalent) of 1990 in Ireland to that in Japan?
Offer a terse response. 0. What is the ratio of the SF6 emissions (in thousand metric tons of CO2 equivalent) of 2000 in Ireland to that in Japan?
Give a very brief answer. 0.01. What is the ratio of the SF6 emissions (in thousand metric tons of CO2 equivalent) of 2005 in Ireland to that in Japan?
Your response must be concise. 0.01. What is the ratio of the SF6 emissions (in thousand metric tons of CO2 equivalent) of 2008 in Ireland to that in Japan?
Make the answer very short. 0.02. What is the ratio of the SF6 emissions (in thousand metric tons of CO2 equivalent) of 1990 in Ireland to that in Korea (Republic)?
Make the answer very short. 0.01. What is the ratio of the SF6 emissions (in thousand metric tons of CO2 equivalent) in 2000 in Ireland to that in Korea (Republic)?
Offer a very short reply. 0.02. What is the ratio of the SF6 emissions (in thousand metric tons of CO2 equivalent) in 2005 in Ireland to that in Korea (Republic)?
Provide a succinct answer. 0.01. What is the ratio of the SF6 emissions (in thousand metric tons of CO2 equivalent) in 2008 in Ireland to that in Korea (Republic)?
Provide a short and direct response. 0.01. What is the ratio of the SF6 emissions (in thousand metric tons of CO2 equivalent) of 1990 in Israel to that in Italy?
Give a very brief answer. 0.81. What is the ratio of the SF6 emissions (in thousand metric tons of CO2 equivalent) of 2000 in Israel to that in Italy?
Provide a succinct answer. 0.79. What is the ratio of the SF6 emissions (in thousand metric tons of CO2 equivalent) of 2005 in Israel to that in Italy?
Offer a very short reply. 0.63. What is the ratio of the SF6 emissions (in thousand metric tons of CO2 equivalent) in 2008 in Israel to that in Italy?
Offer a terse response. 0.65. What is the ratio of the SF6 emissions (in thousand metric tons of CO2 equivalent) in 1990 in Israel to that in Japan?
Your answer should be compact. 0.07. What is the ratio of the SF6 emissions (in thousand metric tons of CO2 equivalent) in 2000 in Israel to that in Japan?
Ensure brevity in your answer.  0.14. What is the ratio of the SF6 emissions (in thousand metric tons of CO2 equivalent) of 2005 in Israel to that in Japan?
Offer a terse response. 0.12. What is the ratio of the SF6 emissions (in thousand metric tons of CO2 equivalent) in 2008 in Israel to that in Japan?
Provide a short and direct response. 0.15. What is the ratio of the SF6 emissions (in thousand metric tons of CO2 equivalent) of 1990 in Israel to that in Korea (Republic)?
Offer a terse response. 0.29. What is the ratio of the SF6 emissions (in thousand metric tons of CO2 equivalent) of 2000 in Israel to that in Korea (Republic)?
Your answer should be very brief. 0.25. What is the ratio of the SF6 emissions (in thousand metric tons of CO2 equivalent) of 2005 in Israel to that in Korea (Republic)?
Offer a terse response. 0.12. What is the ratio of the SF6 emissions (in thousand metric tons of CO2 equivalent) of 2008 in Israel to that in Korea (Republic)?
Provide a short and direct response. 0.11. What is the ratio of the SF6 emissions (in thousand metric tons of CO2 equivalent) in 1990 in Italy to that in Japan?
Offer a terse response. 0.09. What is the ratio of the SF6 emissions (in thousand metric tons of CO2 equivalent) in 2000 in Italy to that in Japan?
Keep it short and to the point. 0.18. What is the ratio of the SF6 emissions (in thousand metric tons of CO2 equivalent) in 2005 in Italy to that in Japan?
Your answer should be very brief. 0.19. What is the ratio of the SF6 emissions (in thousand metric tons of CO2 equivalent) of 2008 in Italy to that in Japan?
Give a very brief answer. 0.23. What is the ratio of the SF6 emissions (in thousand metric tons of CO2 equivalent) of 1990 in Italy to that in Korea (Republic)?
Make the answer very short. 0.35. What is the ratio of the SF6 emissions (in thousand metric tons of CO2 equivalent) in 2000 in Italy to that in Korea (Republic)?
Ensure brevity in your answer.  0.31. What is the ratio of the SF6 emissions (in thousand metric tons of CO2 equivalent) of 2005 in Italy to that in Korea (Republic)?
Keep it short and to the point. 0.19. What is the ratio of the SF6 emissions (in thousand metric tons of CO2 equivalent) of 2008 in Italy to that in Korea (Republic)?
Ensure brevity in your answer.  0.17. What is the ratio of the SF6 emissions (in thousand metric tons of CO2 equivalent) of 1990 in Japan to that in Korea (Republic)?
Ensure brevity in your answer.  4.15. What is the ratio of the SF6 emissions (in thousand metric tons of CO2 equivalent) in 2000 in Japan to that in Korea (Republic)?
Give a very brief answer. 1.77. What is the ratio of the SF6 emissions (in thousand metric tons of CO2 equivalent) of 2005 in Japan to that in Korea (Republic)?
Ensure brevity in your answer.  0.98. What is the ratio of the SF6 emissions (in thousand metric tons of CO2 equivalent) in 2008 in Japan to that in Korea (Republic)?
Your answer should be compact. 0.74. What is the difference between the highest and the second highest SF6 emissions (in thousand metric tons of CO2 equivalent) of 1990?
Make the answer very short. 1.10e+04. What is the difference between the highest and the second highest SF6 emissions (in thousand metric tons of CO2 equivalent) in 2000?
Offer a very short reply. 3106.1. What is the difference between the highest and the second highest SF6 emissions (in thousand metric tons of CO2 equivalent) in 2005?
Offer a very short reply. 93.4. What is the difference between the highest and the second highest SF6 emissions (in thousand metric tons of CO2 equivalent) in 2008?
Provide a succinct answer. 1548.9. What is the difference between the highest and the lowest SF6 emissions (in thousand metric tons of CO2 equivalent) of 1990?
Offer a very short reply. 1.44e+04. What is the difference between the highest and the lowest SF6 emissions (in thousand metric tons of CO2 equivalent) in 2000?
Your answer should be compact. 7080.1. What is the difference between the highest and the lowest SF6 emissions (in thousand metric tons of CO2 equivalent) of 2005?
Your response must be concise. 4553.9. What is the difference between the highest and the lowest SF6 emissions (in thousand metric tons of CO2 equivalent) in 2008?
Offer a terse response. 5861.7. 